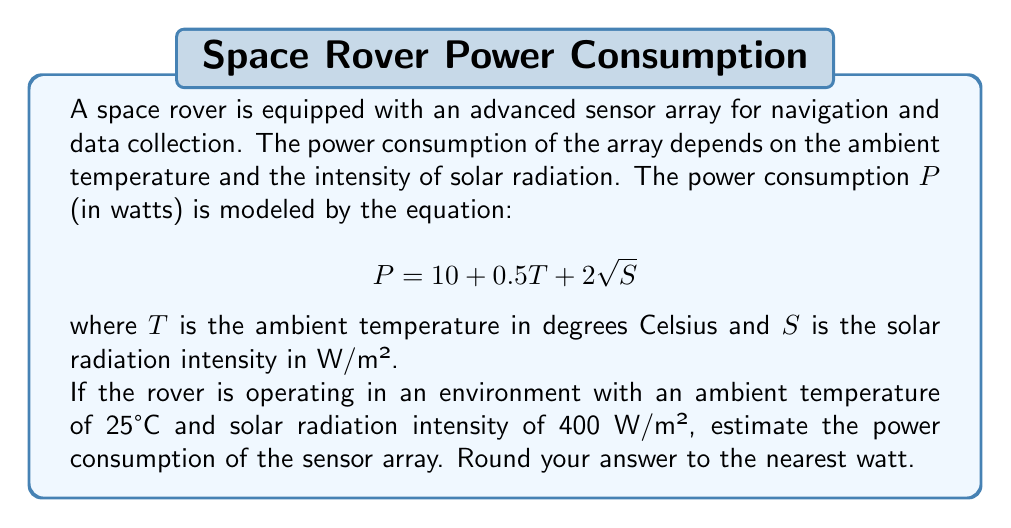Could you help me with this problem? To solve this problem, we need to substitute the given values into the equation and calculate the result. Let's break it down step by step:

1. Given equation: 
   $$P = 10 + 0.5T + 2\sqrt{S}$$

2. Given values:
   $T = 25°C$
   $S = 400$ W/m²

3. Substituting these values into the equation:
   $$P = 10 + 0.5(25) + 2\sqrt{400}$$

4. Simplify the expression:
   $$P = 10 + 12.5 + 2\sqrt{400}$$
   $$P = 22.5 + 2\sqrt{400}$$

5. Calculate the square root:
   $$P = 22.5 + 2(20)$$
   $$P = 22.5 + 40$$

6. Final calculation:
   $$P = 62.5\text{ W}$$

7. Rounding to the nearest watt:
   $$P \approx 63\text{ W}$$

Therefore, the estimated power consumption of the rover's sensor array is 63 watts.
Answer: 63 W 